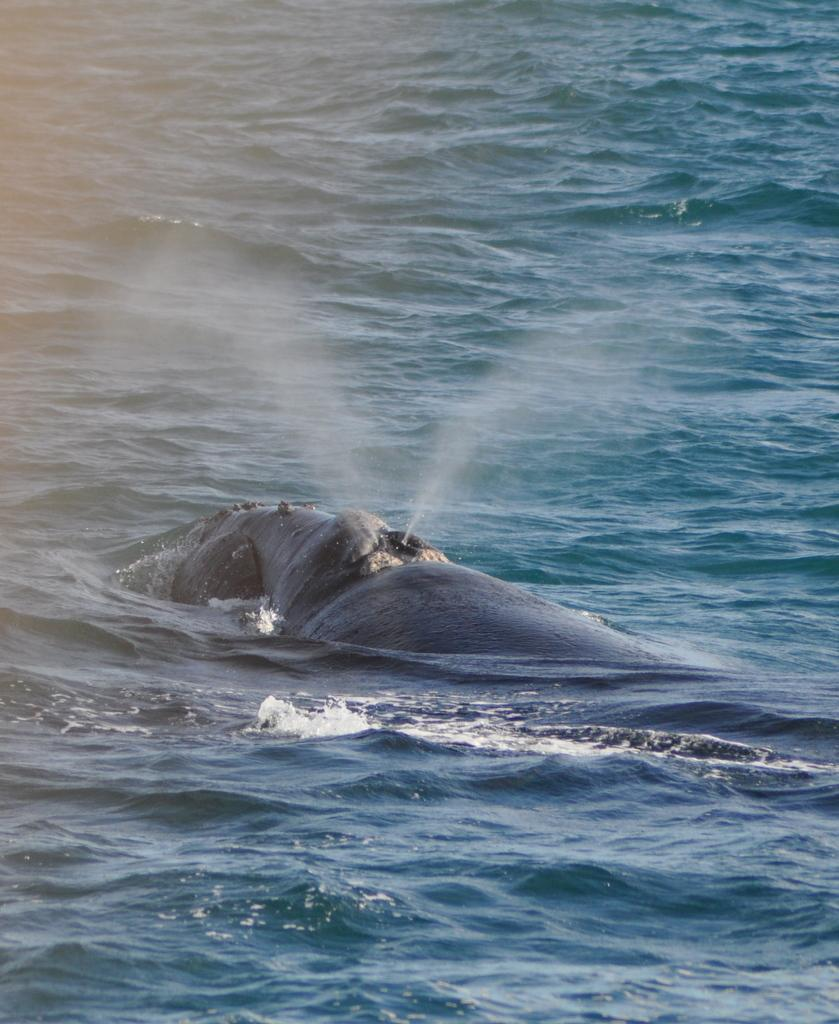What animal is the main subject of the image? There is a whale in the image. What is the whale doing in the image? The whale is swimming in the water. What type of environment is visible in the background of the image? There is an ocean visible in the background of the image. What is the whale's current debt situation in the image? There is no information about the whale's debt situation in the image, as whales do not have financial obligations. 